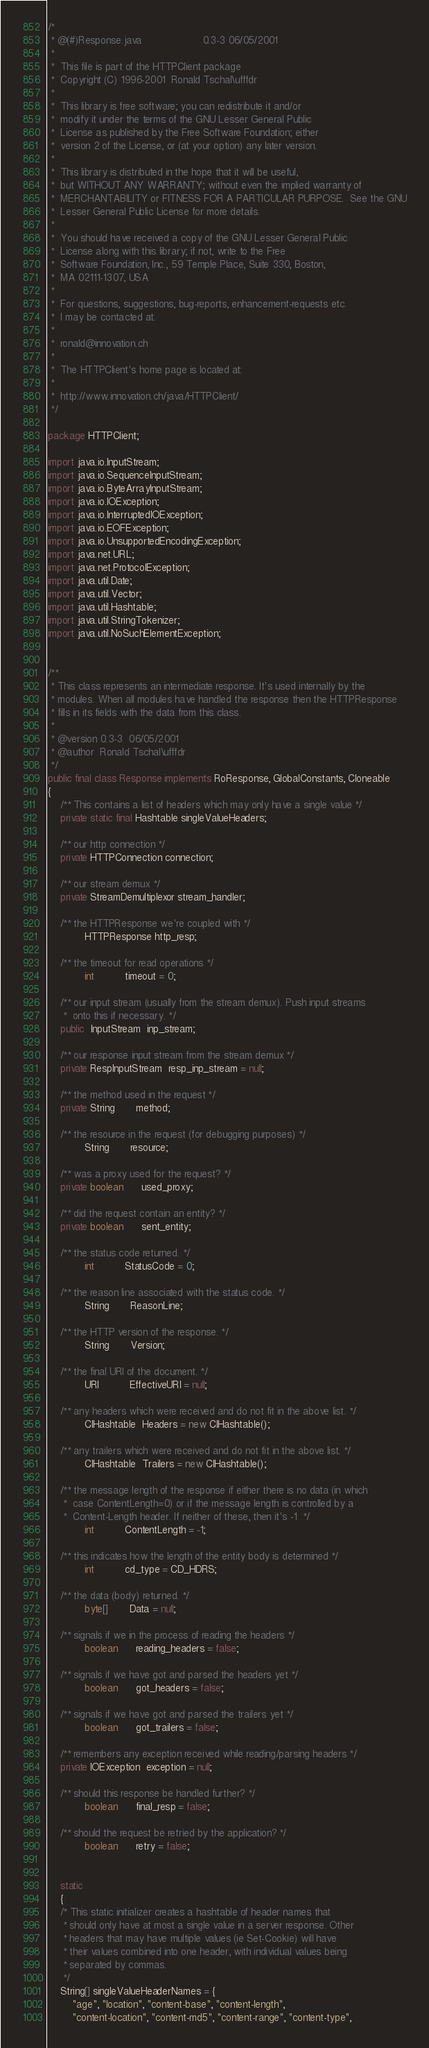Convert code to text. <code><loc_0><loc_0><loc_500><loc_500><_Java_>/*
 * @(#)Response.java					0.3-3 06/05/2001
 *
 *  This file is part of the HTTPClient package
 *  Copyright (C) 1996-2001  Ronald Tschal\ufffdr
 *
 *  This library is free software; you can redistribute it and/or
 *  modify it under the terms of the GNU Lesser General Public
 *  License as published by the Free Software Foundation; either
 *  version 2 of the License, or (at your option) any later version.
 *
 *  This library is distributed in the hope that it will be useful,
 *  but WITHOUT ANY WARRANTY; without even the implied warranty of
 *  MERCHANTABILITY or FITNESS FOR A PARTICULAR PURPOSE.  See the GNU
 *  Lesser General Public License for more details.
 *
 *  You should have received a copy of the GNU Lesser General Public
 *  License along with this library; if not, write to the Free
 *  Software Foundation, Inc., 59 Temple Place, Suite 330, Boston,
 *  MA 02111-1307, USA
 *
 *  For questions, suggestions, bug-reports, enhancement-requests etc.
 *  I may be contacted at:
 *
 *  ronald@innovation.ch
 *
 *  The HTTPClient's home page is located at:
 *
 *  http://www.innovation.ch/java/HTTPClient/ 
 */

package HTTPClient;

import java.io.InputStream;
import java.io.SequenceInputStream;
import java.io.ByteArrayInputStream;
import java.io.IOException;
import java.io.InterruptedIOException;
import java.io.EOFException;
import java.io.UnsupportedEncodingException;
import java.net.URL;
import java.net.ProtocolException;
import java.util.Date;
import java.util.Vector;
import java.util.Hashtable;
import java.util.StringTokenizer;
import java.util.NoSuchElementException;


/**
 * This class represents an intermediate response. It's used internally by the
 * modules. When all modules have handled the response then the HTTPResponse
 * fills in its fields with the data from this class.
 *
 * @version	0.3-3  06/05/2001
 * @author	Ronald Tschal\ufffdr
 */
public final class Response implements RoResponse, GlobalConstants, Cloneable
{
    /** This contains a list of headers which may only have a single value */
    private static final Hashtable singleValueHeaders;

    /** our http connection */
    private HTTPConnection connection;

    /** our stream demux */
    private StreamDemultiplexor stream_handler;

    /** the HTTPResponse we're coupled with */
            HTTPResponse http_resp;

    /** the timeout for read operations */
            int          timeout = 0;

    /** our input stream (usually from the stream demux). Push input streams
     *  onto this if necessary. */
    public  InputStream  inp_stream;

    /** our response input stream from the stream demux */
    private RespInputStream  resp_inp_stream = null;

    /** the method used in the request */
    private String       method;

    /** the resource in the request (for debugging purposes) */
            String       resource;

    /** was a proxy used for the request? */
    private boolean      used_proxy;

    /** did the request contain an entity? */
    private boolean      sent_entity;

    /** the status code returned. */
            int          StatusCode = 0;

    /** the reason line associated with the status code. */
            String       ReasonLine;

    /** the HTTP version of the response. */
            String       Version;

    /** the final URI of the document. */
            URI          EffectiveURI = null;

    /** any headers which were received and do not fit in the above list. */
            CIHashtable  Headers = new CIHashtable();

    /** any trailers which were received and do not fit in the above list. */
            CIHashtable  Trailers = new CIHashtable();

    /** the message length of the response if either there is no data (in which
     *  case ContentLength=0) or if the message length is controlled by a
     *  Content-Length header. If neither of these, then it's -1  */
            int          ContentLength = -1;

    /** this indicates how the length of the entity body is determined */
            int          cd_type = CD_HDRS;

    /** the data (body) returned. */
            byte[]       Data = null;

    /** signals if we in the process of reading the headers */
            boolean      reading_headers = false;

    /** signals if we have got and parsed the headers yet */
            boolean      got_headers = false;

    /** signals if we have got and parsed the trailers yet */
            boolean      got_trailers = false;

    /** remembers any exception received while reading/parsing headers */
    private IOException  exception = null;

    /** should this response be handled further? */
            boolean      final_resp = false;

    /** should the request be retried by the application? */
            boolean      retry = false;


    static
    {
	/* This static initializer creates a hashtable of header names that
	 * should only have at most a single value in a server response. Other
	 * headers that may have multiple values (ie Set-Cookie) will have
	 * their values combined into one header, with individual values being
	 * separated by commas.
	 */
	String[] singleValueHeaderNames = {
	    "age", "location", "content-base", "content-length",
	    "content-location", "content-md5", "content-range", "content-type",</code> 